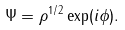<formula> <loc_0><loc_0><loc_500><loc_500>\Psi = \rho ^ { 1 / 2 } \exp ( i \phi ) .</formula> 